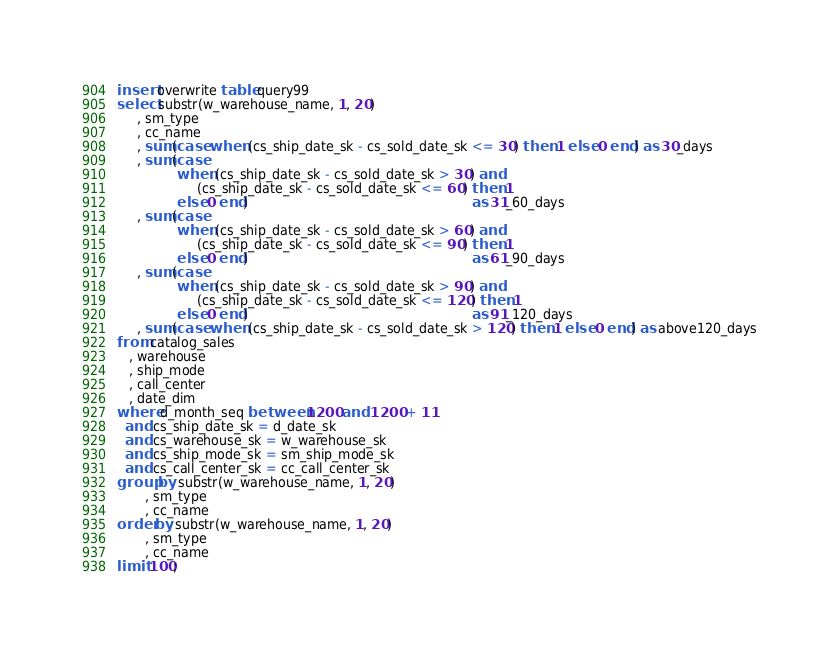<code> <loc_0><loc_0><loc_500><loc_500><_SQL_>insert overwrite table query99
select substr(w_warehouse_name, 1, 20)
     , sm_type
     , cc_name
     , sum(case when (cs_ship_date_sk - cs_sold_date_sk <= 30) then 1 else 0 end) as 30_days
     , sum(case
               when (cs_ship_date_sk - cs_sold_date_sk > 30) and
                    (cs_ship_date_sk - cs_sold_date_sk <= 60) then 1
               else 0 end)                                                        as 31_60_days
     , sum(case
               when (cs_ship_date_sk - cs_sold_date_sk > 60) and
                    (cs_ship_date_sk - cs_sold_date_sk <= 90) then 1
               else 0 end)                                                        as 61_90_days
     , sum(case
               when (cs_ship_date_sk - cs_sold_date_sk > 90) and
                    (cs_ship_date_sk - cs_sold_date_sk <= 120) then 1
               else 0 end)                                                        as 91_120_days
     , sum(case when (cs_ship_date_sk - cs_sold_date_sk > 120) then 1 else 0 end) as above120_days
from catalog_sales
   , warehouse
   , ship_mode
   , call_center
   , date_dim
where d_month_seq between 1200 and 1200 + 11
  and cs_ship_date_sk = d_date_sk
  and cs_warehouse_sk = w_warehouse_sk
  and cs_ship_mode_sk = sm_ship_mode_sk
  and cs_call_center_sk = cc_call_center_sk
group by substr(w_warehouse_name, 1, 20)
       , sm_type
       , cc_name
order by substr(w_warehouse_name, 1, 20)
       , sm_type
       , cc_name
limit 100;
</code> 